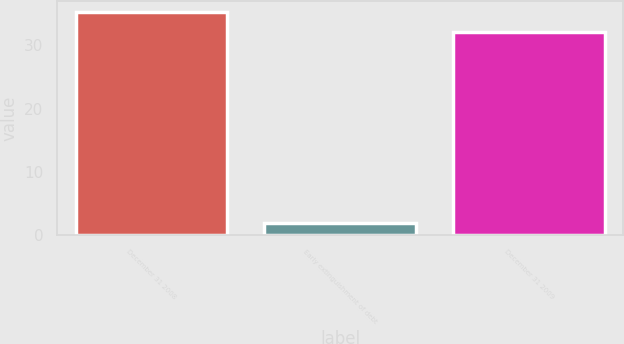<chart> <loc_0><loc_0><loc_500><loc_500><bar_chart><fcel>December 31 2008<fcel>Early extinguishment of debt<fcel>December 31 2009<nl><fcel>35.2<fcel>2<fcel>32<nl></chart> 